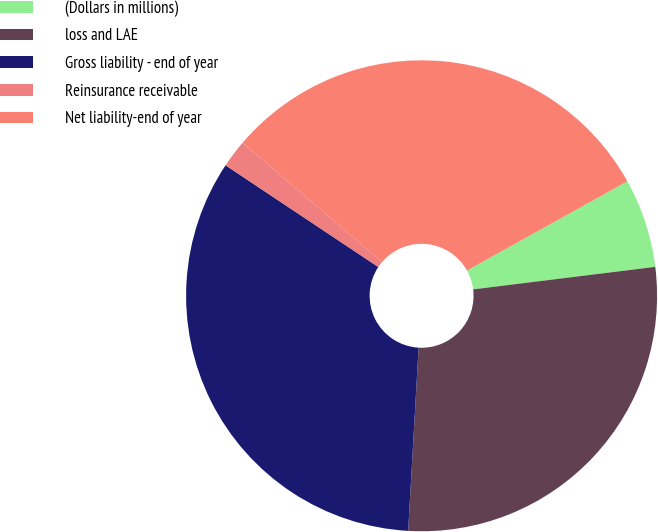Convert chart. <chart><loc_0><loc_0><loc_500><loc_500><pie_chart><fcel>(Dollars in millions)<fcel>loss and LAE<fcel>Gross liability - end of year<fcel>Reinsurance receivable<fcel>Net liability-end of year<nl><fcel>6.12%<fcel>27.87%<fcel>33.44%<fcel>1.91%<fcel>30.66%<nl></chart> 